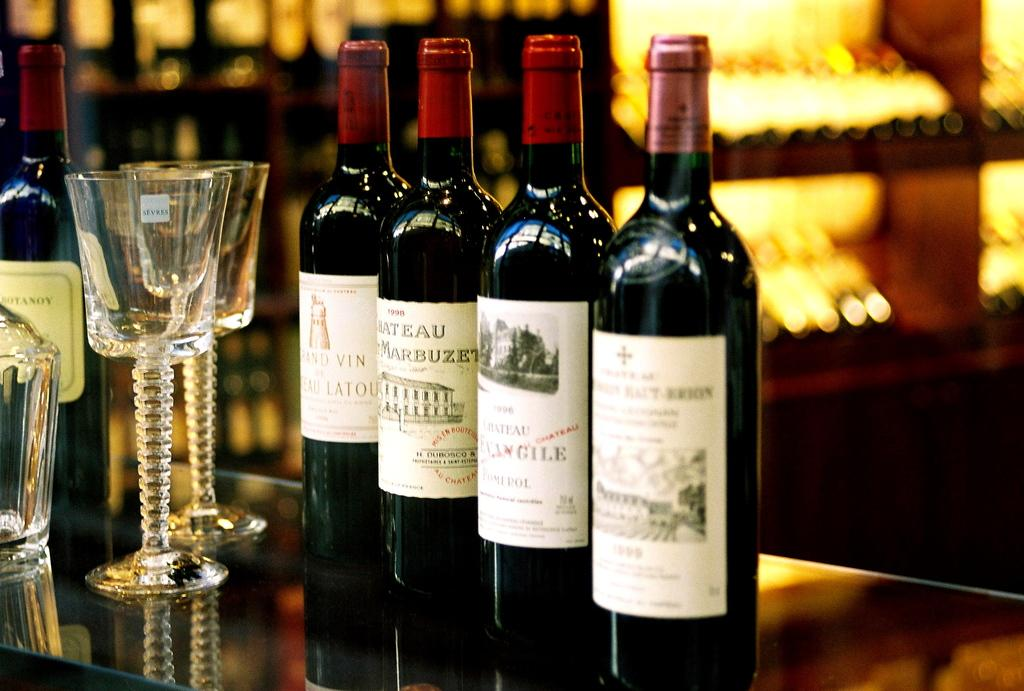Provide a one-sentence caption for the provided image. A bottle of 1998 Marbuzet sits on a table with several other bottles of wine. 